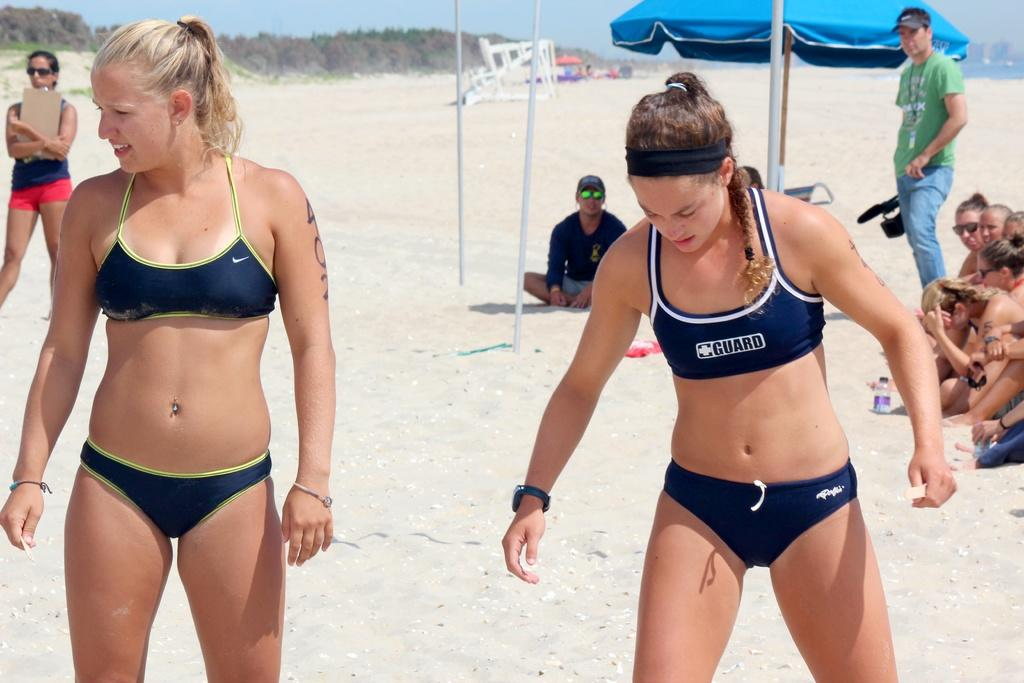Provide a one-sentence caption for the provided image. Two young athletic girl, one with guard on her top is getting ready to play beach volleyball. 